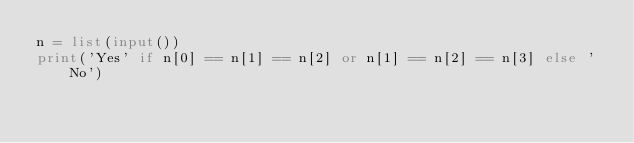<code> <loc_0><loc_0><loc_500><loc_500><_Python_>n = list(input())
print('Yes' if n[0] == n[1] == n[2] or n[1] == n[2] == n[3] else 'No')
</code> 